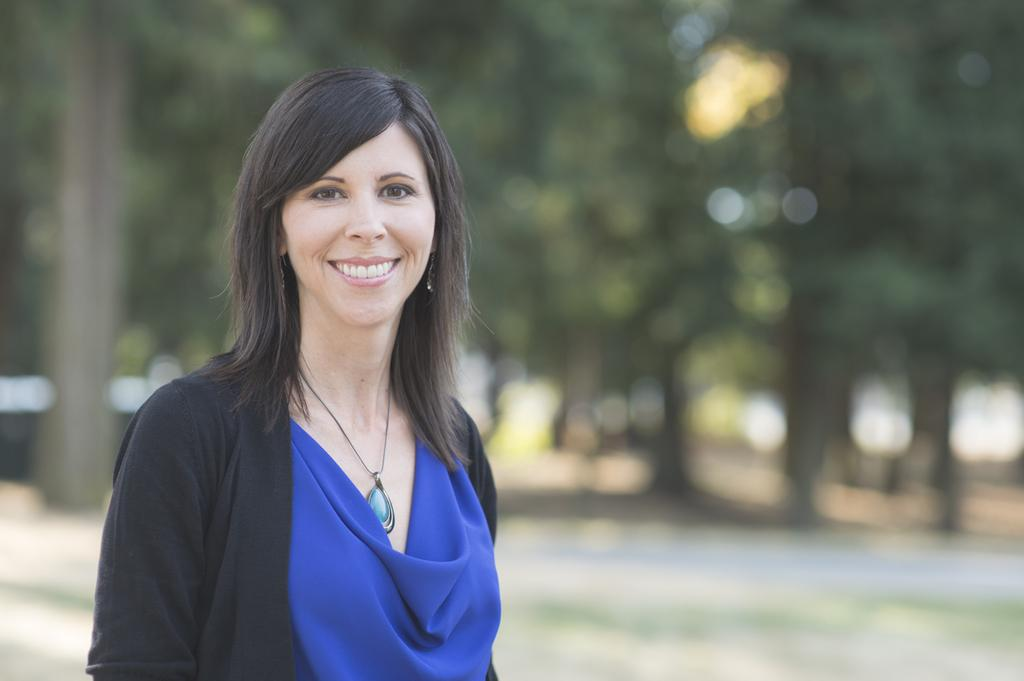Who is present in the image? There is a woman in the image. What is the woman doing in the image? The woman is standing in the image. What expression does the woman have in the image? The woman is smiling in the image. What can be seen in the background of the image? There are trees in the background of the image. What type of border can be seen around the woman in the image? There is no border visible around the woman in the image. 